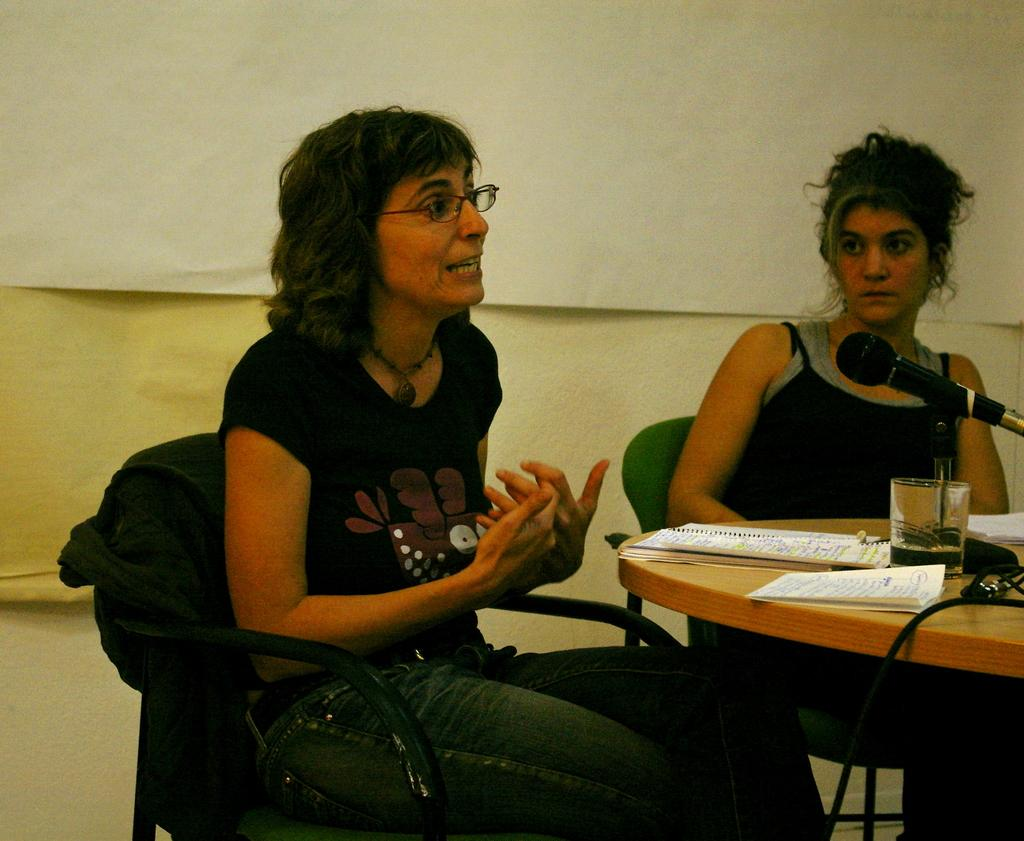How many people are sitting in the image? There are two persons sitting on chairs in the image. What is one of the persons doing? One person is talking. What can be seen on the table in the image? There is a book, a glass, a microphone, and cables on the table. What is the background of the image? There is a wall in the background. What type of building can be seen in the image? There is no building visible in the image. 